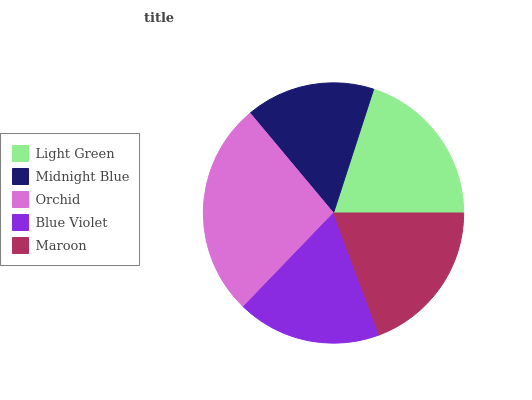Is Midnight Blue the minimum?
Answer yes or no. Yes. Is Orchid the maximum?
Answer yes or no. Yes. Is Orchid the minimum?
Answer yes or no. No. Is Midnight Blue the maximum?
Answer yes or no. No. Is Orchid greater than Midnight Blue?
Answer yes or no. Yes. Is Midnight Blue less than Orchid?
Answer yes or no. Yes. Is Midnight Blue greater than Orchid?
Answer yes or no. No. Is Orchid less than Midnight Blue?
Answer yes or no. No. Is Maroon the high median?
Answer yes or no. Yes. Is Maroon the low median?
Answer yes or no. Yes. Is Orchid the high median?
Answer yes or no. No. Is Blue Violet the low median?
Answer yes or no. No. 